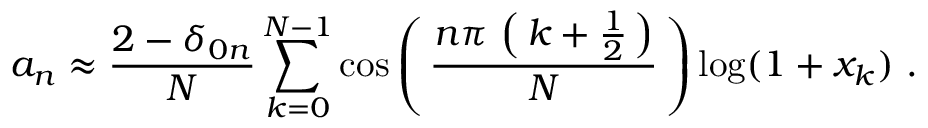<formula> <loc_0><loc_0><loc_500><loc_500>a _ { n } \approx { \frac { 2 - \delta _ { 0 n } } { N } } \sum _ { k = 0 } ^ { N - 1 } \cos \left ( \, { \frac { n \pi \, \left ( \, k + { \frac { 1 } { 2 } } \, \right ) } { N } } \, \right ) \log ( 1 + x _ { k } ) .</formula> 